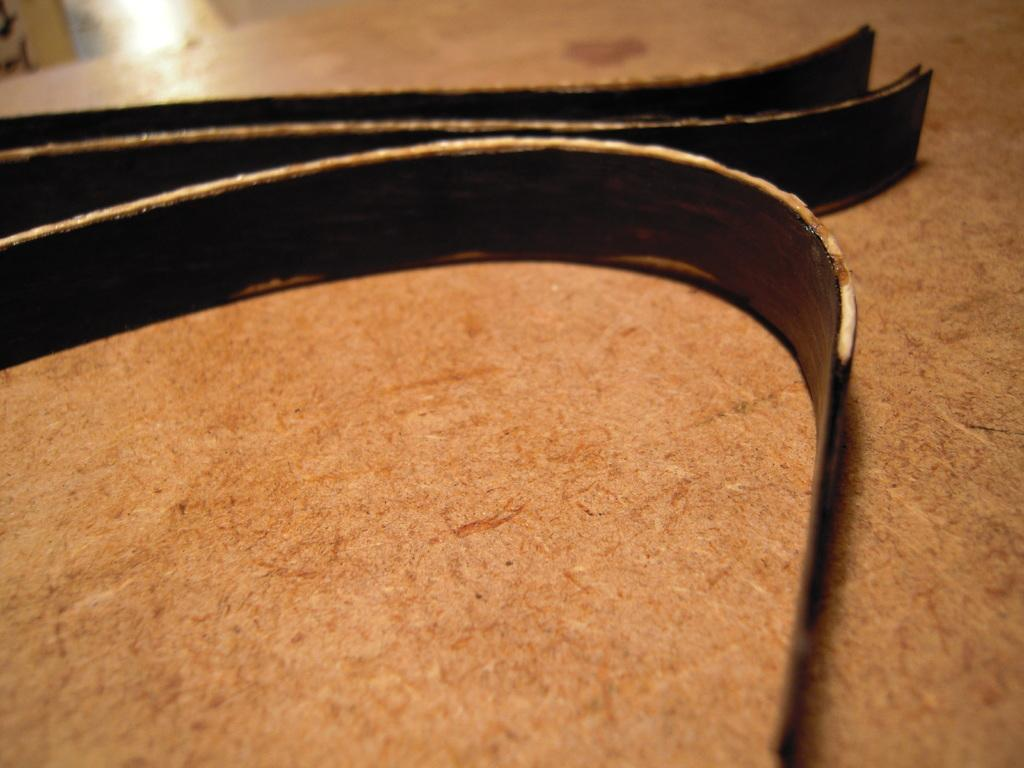What type of objects can be seen in the image? There are iron objects in the image. Where are the iron objects located? The iron objects are on a wooden table. How many rays can be seen coming from the queen in the image? There is no queen or rays present in the image; it features iron objects on a wooden table. 